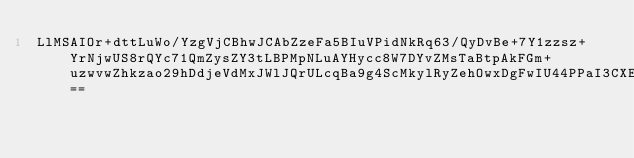Convert code to text. <code><loc_0><loc_0><loc_500><loc_500><_SML_>LlMSAIOr+dttLuWo/YzgVjCBhwJCAbZzeFa5BIuVPidNkRq63/QyDvBe+7Y1zzsz+YrNjwUS8rQYc71QmZysZY3tLBPMpNLuAYHycc8W7DYvZMsTaBtpAkFGm+uzwvwZhkzao29hDdjeVdMxJWlJQrULcqBa9g4ScMkylRyZehOwxDgFwIU44PPaI3CXEbzOkQuPVk8J727WvA==</code> 